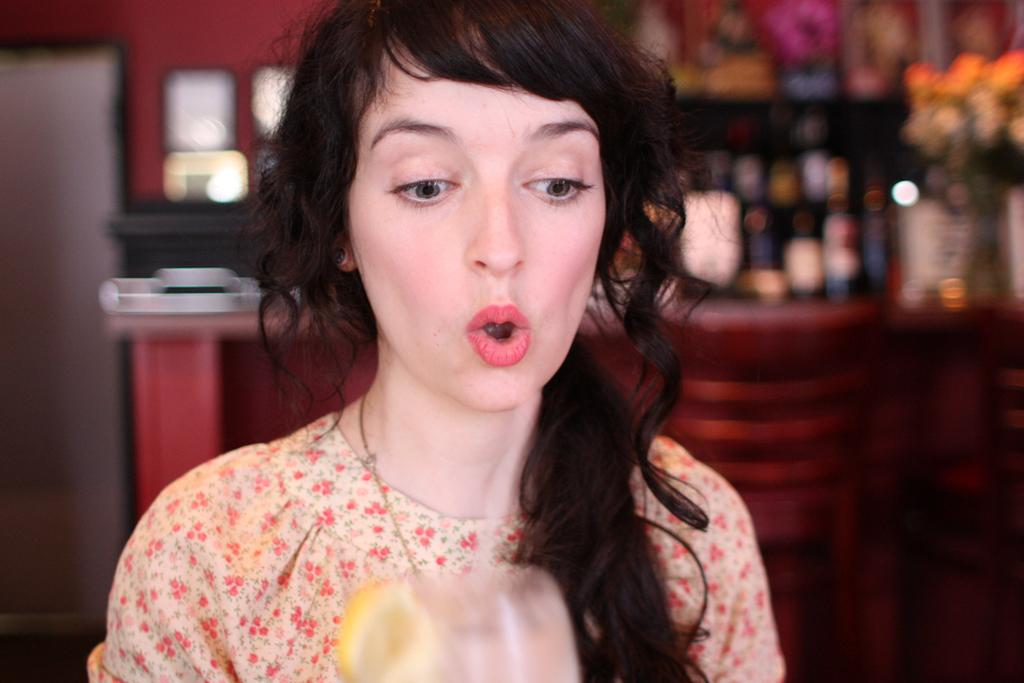Who is the main subject in the image? There is a woman in the image. Can you describe the background of the image? The background of the image is blurry. Is there any blood visible on the woman's clothing in the image? There is no mention of blood or any specific details about the woman's clothing in the provided facts, so it cannot be determined from the image. 